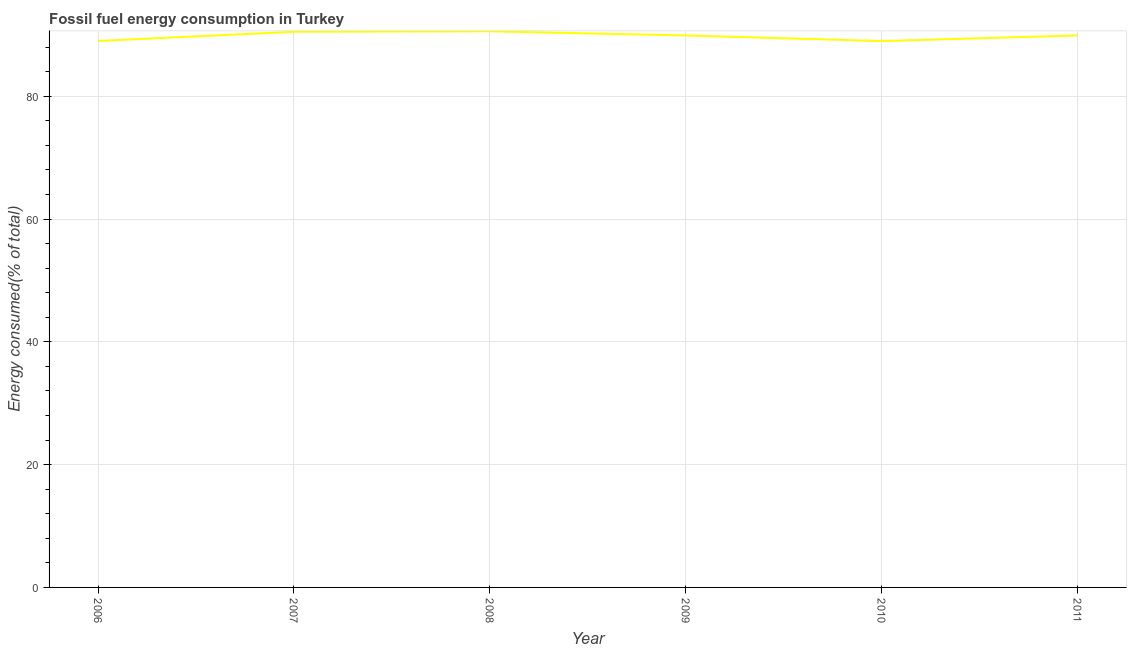What is the fossil fuel energy consumption in 2011?
Give a very brief answer. 89.9. Across all years, what is the maximum fossil fuel energy consumption?
Make the answer very short. 90.57. Across all years, what is the minimum fossil fuel energy consumption?
Make the answer very short. 88.99. In which year was the fossil fuel energy consumption maximum?
Make the answer very short. 2008. In which year was the fossil fuel energy consumption minimum?
Offer a terse response. 2010. What is the sum of the fossil fuel energy consumption?
Your answer should be compact. 538.86. What is the difference between the fossil fuel energy consumption in 2006 and 2008?
Keep it short and to the point. -1.57. What is the average fossil fuel energy consumption per year?
Ensure brevity in your answer.  89.81. What is the median fossil fuel energy consumption?
Keep it short and to the point. 89.9. In how many years, is the fossil fuel energy consumption greater than 84 %?
Keep it short and to the point. 6. What is the ratio of the fossil fuel energy consumption in 2010 to that in 2011?
Your answer should be very brief. 0.99. Is the fossil fuel energy consumption in 2009 less than that in 2010?
Offer a very short reply. No. Is the difference between the fossil fuel energy consumption in 2007 and 2008 greater than the difference between any two years?
Offer a very short reply. No. What is the difference between the highest and the second highest fossil fuel energy consumption?
Give a very brief answer. 0.08. Is the sum of the fossil fuel energy consumption in 2006 and 2007 greater than the maximum fossil fuel energy consumption across all years?
Offer a very short reply. Yes. What is the difference between the highest and the lowest fossil fuel energy consumption?
Your response must be concise. 1.59. Does the fossil fuel energy consumption monotonically increase over the years?
Make the answer very short. No. What is the title of the graph?
Your answer should be very brief. Fossil fuel energy consumption in Turkey. What is the label or title of the Y-axis?
Keep it short and to the point. Energy consumed(% of total). What is the Energy consumed(% of total) of 2006?
Provide a short and direct response. 89.01. What is the Energy consumed(% of total) of 2007?
Keep it short and to the point. 90.5. What is the Energy consumed(% of total) of 2008?
Make the answer very short. 90.57. What is the Energy consumed(% of total) in 2009?
Your answer should be very brief. 89.9. What is the Energy consumed(% of total) of 2010?
Your response must be concise. 88.99. What is the Energy consumed(% of total) in 2011?
Provide a succinct answer. 89.9. What is the difference between the Energy consumed(% of total) in 2006 and 2007?
Your answer should be very brief. -1.49. What is the difference between the Energy consumed(% of total) in 2006 and 2008?
Your answer should be very brief. -1.57. What is the difference between the Energy consumed(% of total) in 2006 and 2009?
Keep it short and to the point. -0.89. What is the difference between the Energy consumed(% of total) in 2006 and 2010?
Your answer should be compact. 0.02. What is the difference between the Energy consumed(% of total) in 2006 and 2011?
Provide a short and direct response. -0.89. What is the difference between the Energy consumed(% of total) in 2007 and 2008?
Offer a terse response. -0.08. What is the difference between the Energy consumed(% of total) in 2007 and 2009?
Offer a very short reply. 0.6. What is the difference between the Energy consumed(% of total) in 2007 and 2010?
Make the answer very short. 1.51. What is the difference between the Energy consumed(% of total) in 2007 and 2011?
Provide a short and direct response. 0.6. What is the difference between the Energy consumed(% of total) in 2008 and 2009?
Your answer should be very brief. 0.68. What is the difference between the Energy consumed(% of total) in 2008 and 2010?
Your response must be concise. 1.59. What is the difference between the Energy consumed(% of total) in 2008 and 2011?
Make the answer very short. 0.68. What is the difference between the Energy consumed(% of total) in 2009 and 2010?
Provide a short and direct response. 0.91. What is the difference between the Energy consumed(% of total) in 2009 and 2011?
Your response must be concise. 0. What is the difference between the Energy consumed(% of total) in 2010 and 2011?
Provide a short and direct response. -0.91. What is the ratio of the Energy consumed(% of total) in 2006 to that in 2011?
Make the answer very short. 0.99. What is the ratio of the Energy consumed(% of total) in 2007 to that in 2010?
Your answer should be very brief. 1.02. What is the ratio of the Energy consumed(% of total) in 2007 to that in 2011?
Keep it short and to the point. 1.01. What is the ratio of the Energy consumed(% of total) in 2008 to that in 2009?
Your answer should be compact. 1.01. What is the ratio of the Energy consumed(% of total) in 2008 to that in 2010?
Provide a short and direct response. 1.02. What is the ratio of the Energy consumed(% of total) in 2009 to that in 2011?
Your answer should be compact. 1. 